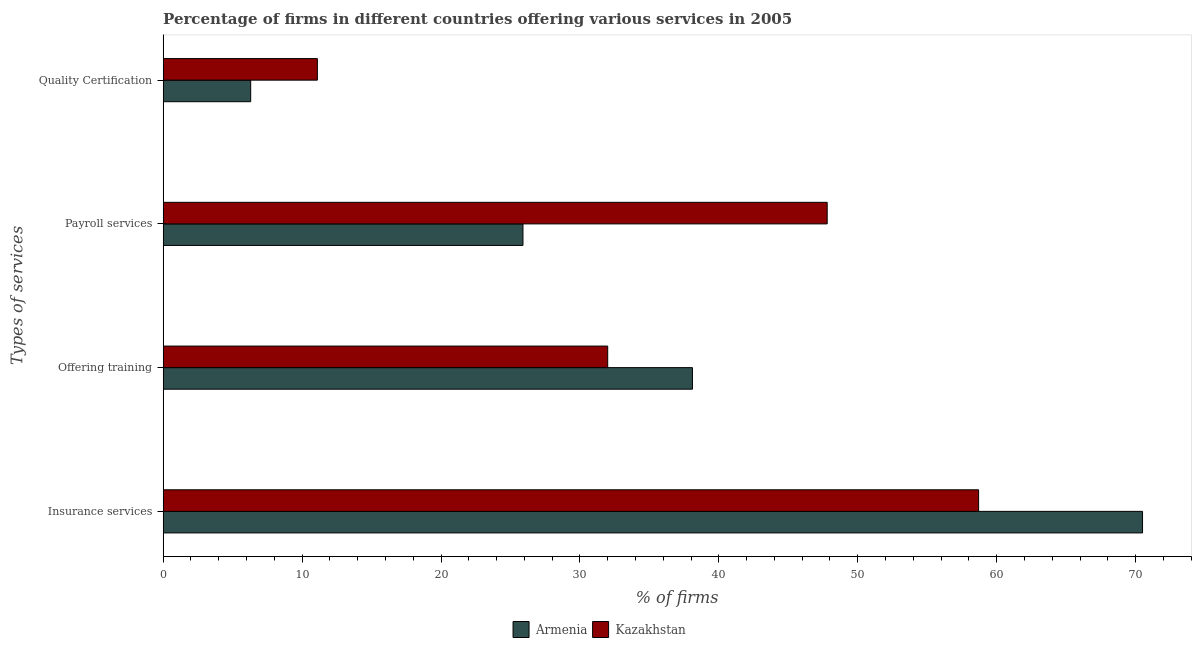How many different coloured bars are there?
Your answer should be compact. 2. Are the number of bars per tick equal to the number of legend labels?
Provide a succinct answer. Yes. How many bars are there on the 1st tick from the top?
Your answer should be very brief. 2. What is the label of the 1st group of bars from the top?
Give a very brief answer. Quality Certification. What is the percentage of firms offering quality certification in Kazakhstan?
Ensure brevity in your answer.  11.1. Across all countries, what is the maximum percentage of firms offering insurance services?
Keep it short and to the point. 70.5. In which country was the percentage of firms offering payroll services maximum?
Ensure brevity in your answer.  Kazakhstan. In which country was the percentage of firms offering quality certification minimum?
Give a very brief answer. Armenia. What is the total percentage of firms offering payroll services in the graph?
Make the answer very short. 73.7. What is the difference between the percentage of firms offering training in Armenia and that in Kazakhstan?
Ensure brevity in your answer.  6.1. What is the difference between the percentage of firms offering quality certification in Kazakhstan and the percentage of firms offering insurance services in Armenia?
Ensure brevity in your answer.  -59.4. What is the average percentage of firms offering training per country?
Your response must be concise. 35.05. What is the difference between the percentage of firms offering insurance services and percentage of firms offering quality certification in Armenia?
Your answer should be very brief. 64.2. In how many countries, is the percentage of firms offering quality certification greater than 30 %?
Make the answer very short. 0. What is the ratio of the percentage of firms offering training in Armenia to that in Kazakhstan?
Keep it short and to the point. 1.19. Is the percentage of firms offering payroll services in Kazakhstan less than that in Armenia?
Offer a terse response. No. Is the difference between the percentage of firms offering quality certification in Armenia and Kazakhstan greater than the difference between the percentage of firms offering training in Armenia and Kazakhstan?
Keep it short and to the point. No. What is the difference between the highest and the second highest percentage of firms offering insurance services?
Your answer should be compact. 11.8. What is the difference between the highest and the lowest percentage of firms offering quality certification?
Provide a short and direct response. 4.8. In how many countries, is the percentage of firms offering insurance services greater than the average percentage of firms offering insurance services taken over all countries?
Provide a succinct answer. 1. Is it the case that in every country, the sum of the percentage of firms offering payroll services and percentage of firms offering quality certification is greater than the sum of percentage of firms offering training and percentage of firms offering insurance services?
Give a very brief answer. No. What does the 1st bar from the top in Quality Certification represents?
Make the answer very short. Kazakhstan. What does the 2nd bar from the bottom in Payroll services represents?
Make the answer very short. Kazakhstan. Is it the case that in every country, the sum of the percentage of firms offering insurance services and percentage of firms offering training is greater than the percentage of firms offering payroll services?
Offer a terse response. Yes. How many bars are there?
Your answer should be compact. 8. How many countries are there in the graph?
Provide a short and direct response. 2. What is the difference between two consecutive major ticks on the X-axis?
Your answer should be compact. 10. Does the graph contain any zero values?
Make the answer very short. No. Does the graph contain grids?
Keep it short and to the point. No. Where does the legend appear in the graph?
Provide a short and direct response. Bottom center. What is the title of the graph?
Your response must be concise. Percentage of firms in different countries offering various services in 2005. What is the label or title of the X-axis?
Offer a very short reply. % of firms. What is the label or title of the Y-axis?
Ensure brevity in your answer.  Types of services. What is the % of firms in Armenia in Insurance services?
Keep it short and to the point. 70.5. What is the % of firms in Kazakhstan in Insurance services?
Your answer should be very brief. 58.7. What is the % of firms in Armenia in Offering training?
Offer a very short reply. 38.1. What is the % of firms of Armenia in Payroll services?
Make the answer very short. 25.9. What is the % of firms in Kazakhstan in Payroll services?
Offer a terse response. 47.8. Across all Types of services, what is the maximum % of firms of Armenia?
Ensure brevity in your answer.  70.5. Across all Types of services, what is the maximum % of firms of Kazakhstan?
Offer a very short reply. 58.7. Across all Types of services, what is the minimum % of firms of Kazakhstan?
Provide a succinct answer. 11.1. What is the total % of firms in Armenia in the graph?
Your response must be concise. 140.8. What is the total % of firms of Kazakhstan in the graph?
Offer a terse response. 149.6. What is the difference between the % of firms of Armenia in Insurance services and that in Offering training?
Provide a succinct answer. 32.4. What is the difference between the % of firms of Kazakhstan in Insurance services and that in Offering training?
Provide a succinct answer. 26.7. What is the difference between the % of firms in Armenia in Insurance services and that in Payroll services?
Ensure brevity in your answer.  44.6. What is the difference between the % of firms in Kazakhstan in Insurance services and that in Payroll services?
Give a very brief answer. 10.9. What is the difference between the % of firms in Armenia in Insurance services and that in Quality Certification?
Make the answer very short. 64.2. What is the difference between the % of firms of Kazakhstan in Insurance services and that in Quality Certification?
Offer a very short reply. 47.6. What is the difference between the % of firms of Kazakhstan in Offering training and that in Payroll services?
Your answer should be very brief. -15.8. What is the difference between the % of firms in Armenia in Offering training and that in Quality Certification?
Make the answer very short. 31.8. What is the difference between the % of firms of Kazakhstan in Offering training and that in Quality Certification?
Your answer should be very brief. 20.9. What is the difference between the % of firms in Armenia in Payroll services and that in Quality Certification?
Keep it short and to the point. 19.6. What is the difference between the % of firms of Kazakhstan in Payroll services and that in Quality Certification?
Offer a terse response. 36.7. What is the difference between the % of firms of Armenia in Insurance services and the % of firms of Kazakhstan in Offering training?
Give a very brief answer. 38.5. What is the difference between the % of firms of Armenia in Insurance services and the % of firms of Kazakhstan in Payroll services?
Give a very brief answer. 22.7. What is the difference between the % of firms in Armenia in Insurance services and the % of firms in Kazakhstan in Quality Certification?
Provide a succinct answer. 59.4. What is the difference between the % of firms in Armenia in Offering training and the % of firms in Kazakhstan in Payroll services?
Provide a succinct answer. -9.7. What is the difference between the % of firms in Armenia in Offering training and the % of firms in Kazakhstan in Quality Certification?
Your response must be concise. 27. What is the average % of firms of Armenia per Types of services?
Offer a very short reply. 35.2. What is the average % of firms in Kazakhstan per Types of services?
Make the answer very short. 37.4. What is the difference between the % of firms of Armenia and % of firms of Kazakhstan in Offering training?
Offer a terse response. 6.1. What is the difference between the % of firms in Armenia and % of firms in Kazakhstan in Payroll services?
Your answer should be very brief. -21.9. What is the ratio of the % of firms in Armenia in Insurance services to that in Offering training?
Offer a very short reply. 1.85. What is the ratio of the % of firms in Kazakhstan in Insurance services to that in Offering training?
Your answer should be very brief. 1.83. What is the ratio of the % of firms of Armenia in Insurance services to that in Payroll services?
Make the answer very short. 2.72. What is the ratio of the % of firms of Kazakhstan in Insurance services to that in Payroll services?
Your answer should be very brief. 1.23. What is the ratio of the % of firms of Armenia in Insurance services to that in Quality Certification?
Provide a succinct answer. 11.19. What is the ratio of the % of firms in Kazakhstan in Insurance services to that in Quality Certification?
Give a very brief answer. 5.29. What is the ratio of the % of firms in Armenia in Offering training to that in Payroll services?
Your answer should be compact. 1.47. What is the ratio of the % of firms of Kazakhstan in Offering training to that in Payroll services?
Offer a very short reply. 0.67. What is the ratio of the % of firms in Armenia in Offering training to that in Quality Certification?
Provide a succinct answer. 6.05. What is the ratio of the % of firms of Kazakhstan in Offering training to that in Quality Certification?
Offer a very short reply. 2.88. What is the ratio of the % of firms in Armenia in Payroll services to that in Quality Certification?
Your answer should be very brief. 4.11. What is the ratio of the % of firms in Kazakhstan in Payroll services to that in Quality Certification?
Make the answer very short. 4.31. What is the difference between the highest and the second highest % of firms in Armenia?
Offer a very short reply. 32.4. What is the difference between the highest and the second highest % of firms in Kazakhstan?
Offer a terse response. 10.9. What is the difference between the highest and the lowest % of firms in Armenia?
Ensure brevity in your answer.  64.2. What is the difference between the highest and the lowest % of firms in Kazakhstan?
Provide a succinct answer. 47.6. 